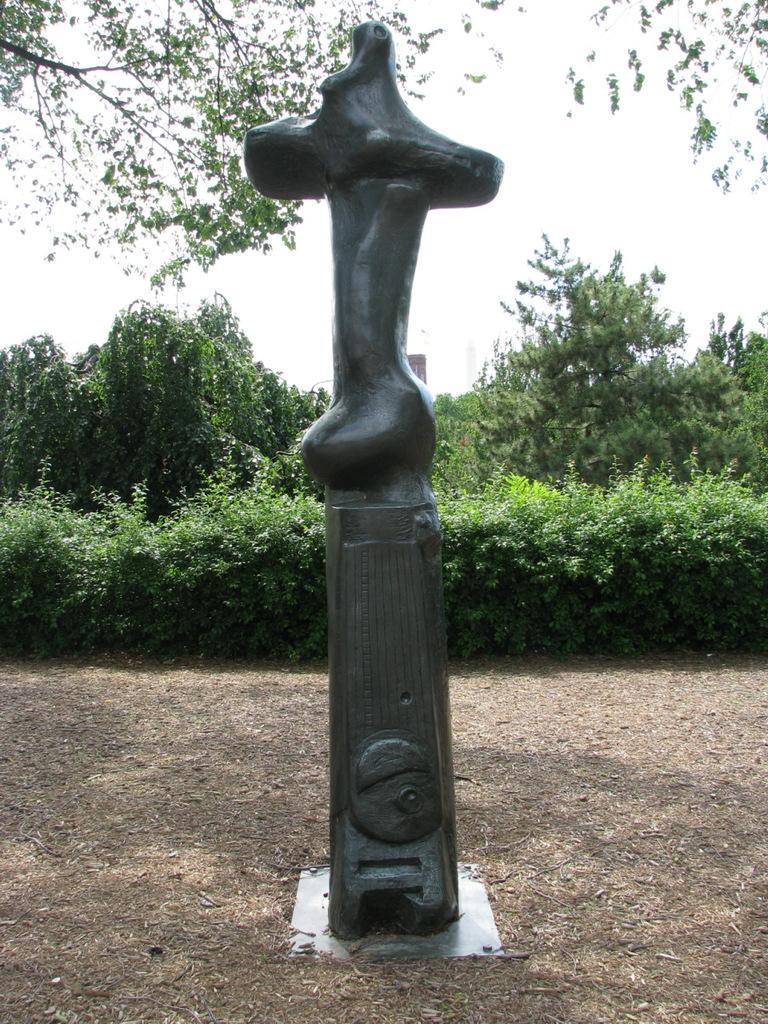Describe this image in one or two sentences. In this picture we can see a sculpture in front, in the bottom we can see soil, in the background there are some plants and trees. 